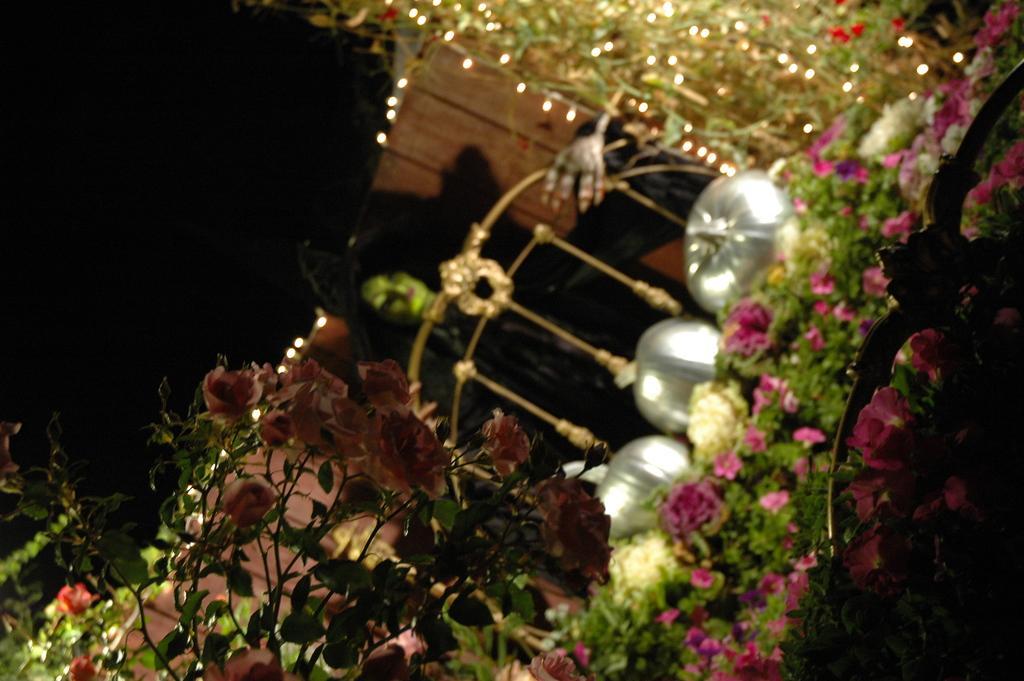Please provide a concise description of this image. In this image I can see number of flowers in the front and in the background I can see a black colour thing. On the top of this image I can see few lights. 